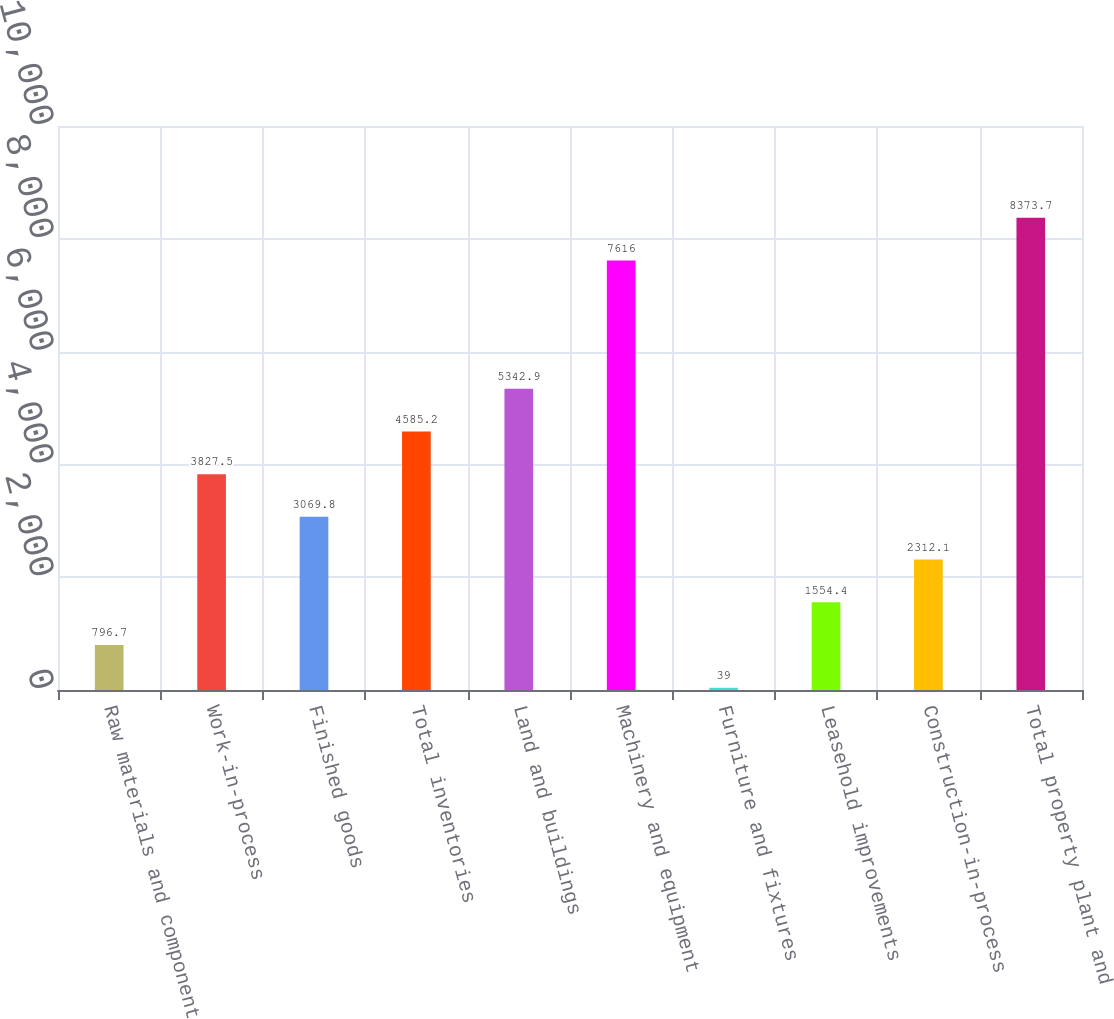<chart> <loc_0><loc_0><loc_500><loc_500><bar_chart><fcel>Raw materials and component<fcel>Work-in-process<fcel>Finished goods<fcel>Total inventories<fcel>Land and buildings<fcel>Machinery and equipment<fcel>Furniture and fixtures<fcel>Leasehold improvements<fcel>Construction-in-process<fcel>Total property plant and<nl><fcel>796.7<fcel>3827.5<fcel>3069.8<fcel>4585.2<fcel>5342.9<fcel>7616<fcel>39<fcel>1554.4<fcel>2312.1<fcel>8373.7<nl></chart> 